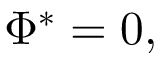<formula> <loc_0><loc_0><loc_500><loc_500>\Phi ^ { * } = 0 ,</formula> 